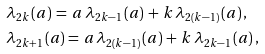Convert formula to latex. <formula><loc_0><loc_0><loc_500><loc_500>& \lambda _ { 2 k } \, ( a ) \, = \, a \, \lambda _ { 2 k - 1 } \, ( a ) \, + \, k \, \lambda _ { 2 ( k - 1 ) } \, ( a ) \, , \\ & \lambda _ { 2 k + 1 } \, ( a ) = \, a \, \lambda _ { 2 ( k - 1 ) } \, ( a ) \, + \, k \, \lambda _ { 2 k - 1 } \, ( a ) \, ,</formula> 